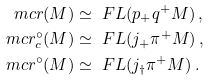Convert formula to latex. <formula><loc_0><loc_0><loc_500><loc_500>\ m c r ( M ) & \simeq \ F L ( p _ { + } q ^ { + } M ) \, , \\ \ m c r ^ { \circ } _ { c } ( M ) & \simeq \ F L ( j _ { + } \pi ^ { + } M ) \, , \\ \ m c r ^ { \circ } ( M ) & \simeq \ F L ( j _ { \dag } \pi ^ { + } M ) \, .</formula> 